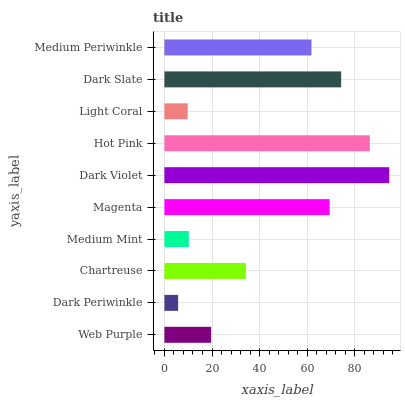Is Dark Periwinkle the minimum?
Answer yes or no. Yes. Is Dark Violet the maximum?
Answer yes or no. Yes. Is Chartreuse the minimum?
Answer yes or no. No. Is Chartreuse the maximum?
Answer yes or no. No. Is Chartreuse greater than Dark Periwinkle?
Answer yes or no. Yes. Is Dark Periwinkle less than Chartreuse?
Answer yes or no. Yes. Is Dark Periwinkle greater than Chartreuse?
Answer yes or no. No. Is Chartreuse less than Dark Periwinkle?
Answer yes or no. No. Is Medium Periwinkle the high median?
Answer yes or no. Yes. Is Chartreuse the low median?
Answer yes or no. Yes. Is Dark Slate the high median?
Answer yes or no. No. Is Medium Periwinkle the low median?
Answer yes or no. No. 